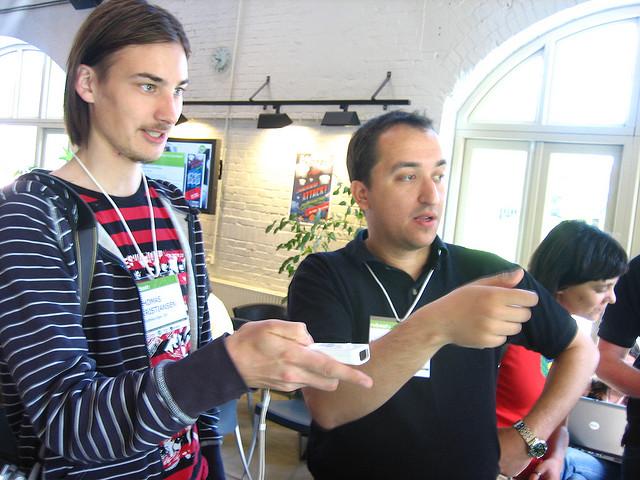What type of remote is in the man's hand?
Keep it brief. Wii. How many people are there?
Be succinct. 4. What are the wearing around their necks?
Short answer required. Name tags. 